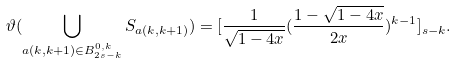<formula> <loc_0><loc_0><loc_500><loc_500>\vartheta ( \bigcup _ { a ( k , k + 1 ) \in B _ { 2 s - k } ^ { 0 , k } } S _ { a ( k , k + 1 ) } ) = [ \frac { 1 } { \sqrt { 1 - 4 x } } ( \frac { 1 - \sqrt { 1 - 4 x } } { 2 x } ) ^ { k - 1 } ] _ { s - k } .</formula> 